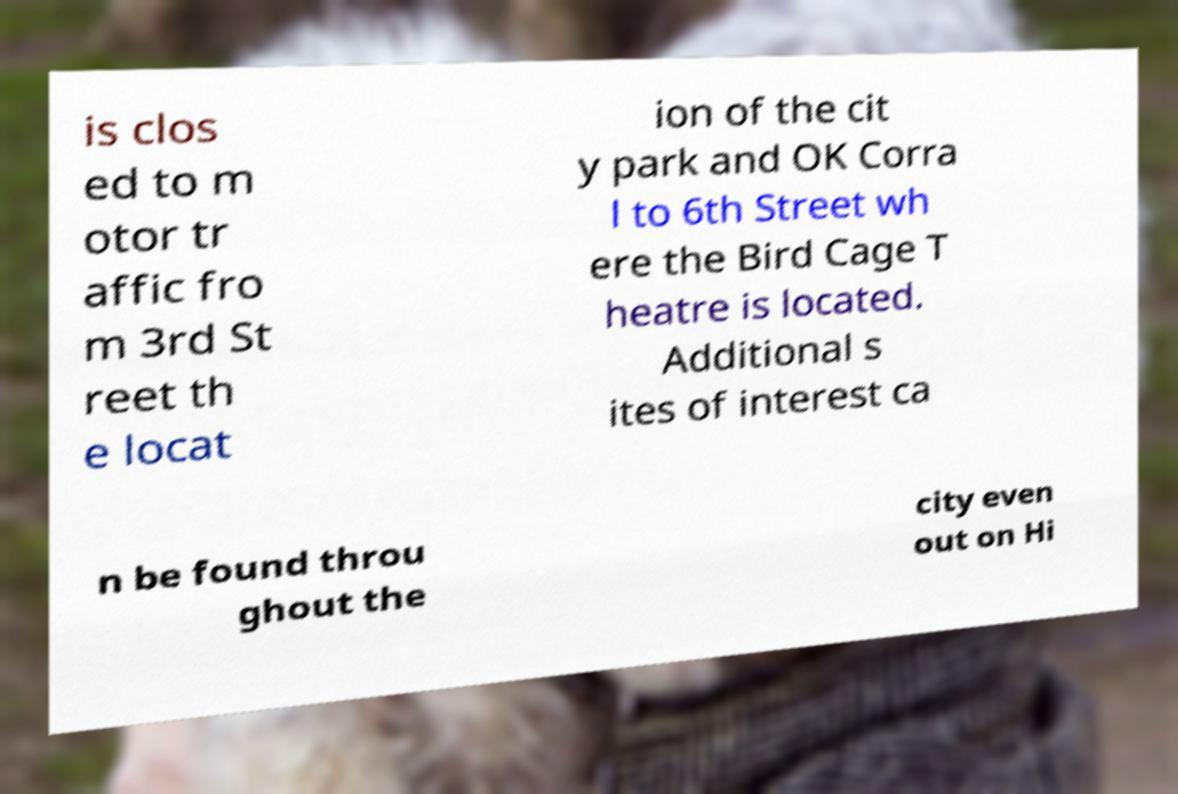Can you read and provide the text displayed in the image?This photo seems to have some interesting text. Can you extract and type it out for me? is clos ed to m otor tr affic fro m 3rd St reet th e locat ion of the cit y park and OK Corra l to 6th Street wh ere the Bird Cage T heatre is located. Additional s ites of interest ca n be found throu ghout the city even out on Hi 